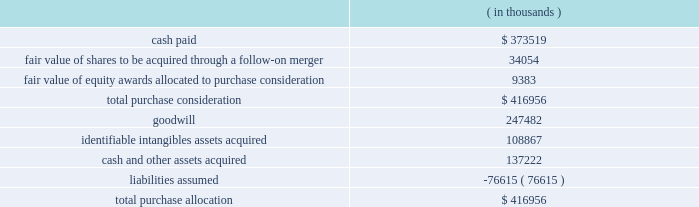Synopsys , inc .
Notes to consolidated financial statements 2014continued the aggregate purchase price consideration was approximately us$ 417.0 million .
As of october 31 , 2012 , the total purchase consideration and the preliminary purchase price allocation were as follows: .
Goodwill of $ 247.5 million , which is generally not deductible for tax purposes , primarily resulted from the company 2019s expectation of sales growth and cost synergies from the integration of springsoft 2019s technology and operations with the company 2019s technology and operations .
Identifiable intangible assets , consisting primarily of technology , customer relationships , backlog and trademarks , were valued using the income method , and are being amortized over three to eight years .
Acquisition-related costs directly attributable to the business combination were $ 6.6 million for fiscal 2012 and were expensed as incurred in the consolidated statements of operations .
These costs consisted primarily of employee separation costs and professional services .
Fair value of equity awards : pursuant to the merger agreement , the company assumed all the unvested outstanding stock options of springsoft upon the completion of the merger and the vested options were exchanged for cash in the merger .
On october 1 , 2012 , the date of the completion of the tender offer , the fair value of the awards to be assumed and exchanged was $ 9.9 million , calculated using the black-scholes option pricing model .
The black-scholes option-pricing model incorporates various subjective assumptions including expected volatility , expected term and risk-free interest rates .
The expected volatility was estimated by a combination of implied and historical stock price volatility of the options .
Non-controlling interest : non-controlling interest represents the fair value of the 8.4% ( 8.4 % ) of outstanding springsoft shares that were not acquired during the tender offer process completed on october 1 , 2012 and the fair value of the option awards that were to be assumed or exchanged for cash upon the follow-on merger .
The fair value of the non-controlling interest included as part of the aggregate purchase consideration was $ 42.8 million and is disclosed as a separate line in the october 31 , 2012 consolidated statements of stockholders 2019 equity .
During the period between the completion of the tender offer and the end of the company 2019s fiscal year on october 31 , 2012 , the non-controlling interest was adjusted by $ 0.5 million to reflect the non-controlling interest 2019s share of the operating loss of springsoft in that period .
As the amount is not significant , it has been included as part of other income ( expense ) , net , in the consolidated statements of operations. .
What percentage of total purchase allocation is goodwill? 
Computations: (247482 / 416956)
Answer: 0.59354. 